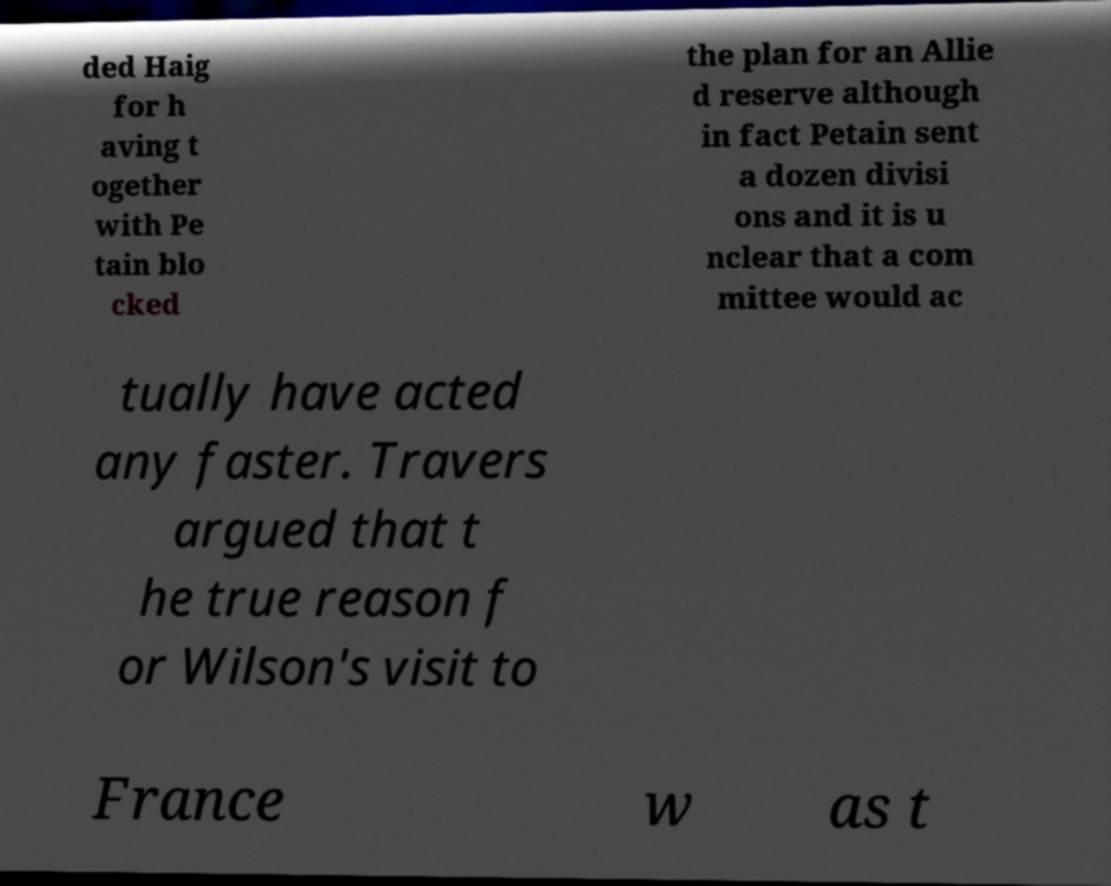What messages or text are displayed in this image? I need them in a readable, typed format. ded Haig for h aving t ogether with Pe tain blo cked the plan for an Allie d reserve although in fact Petain sent a dozen divisi ons and it is u nclear that a com mittee would ac tually have acted any faster. Travers argued that t he true reason f or Wilson's visit to France w as t 